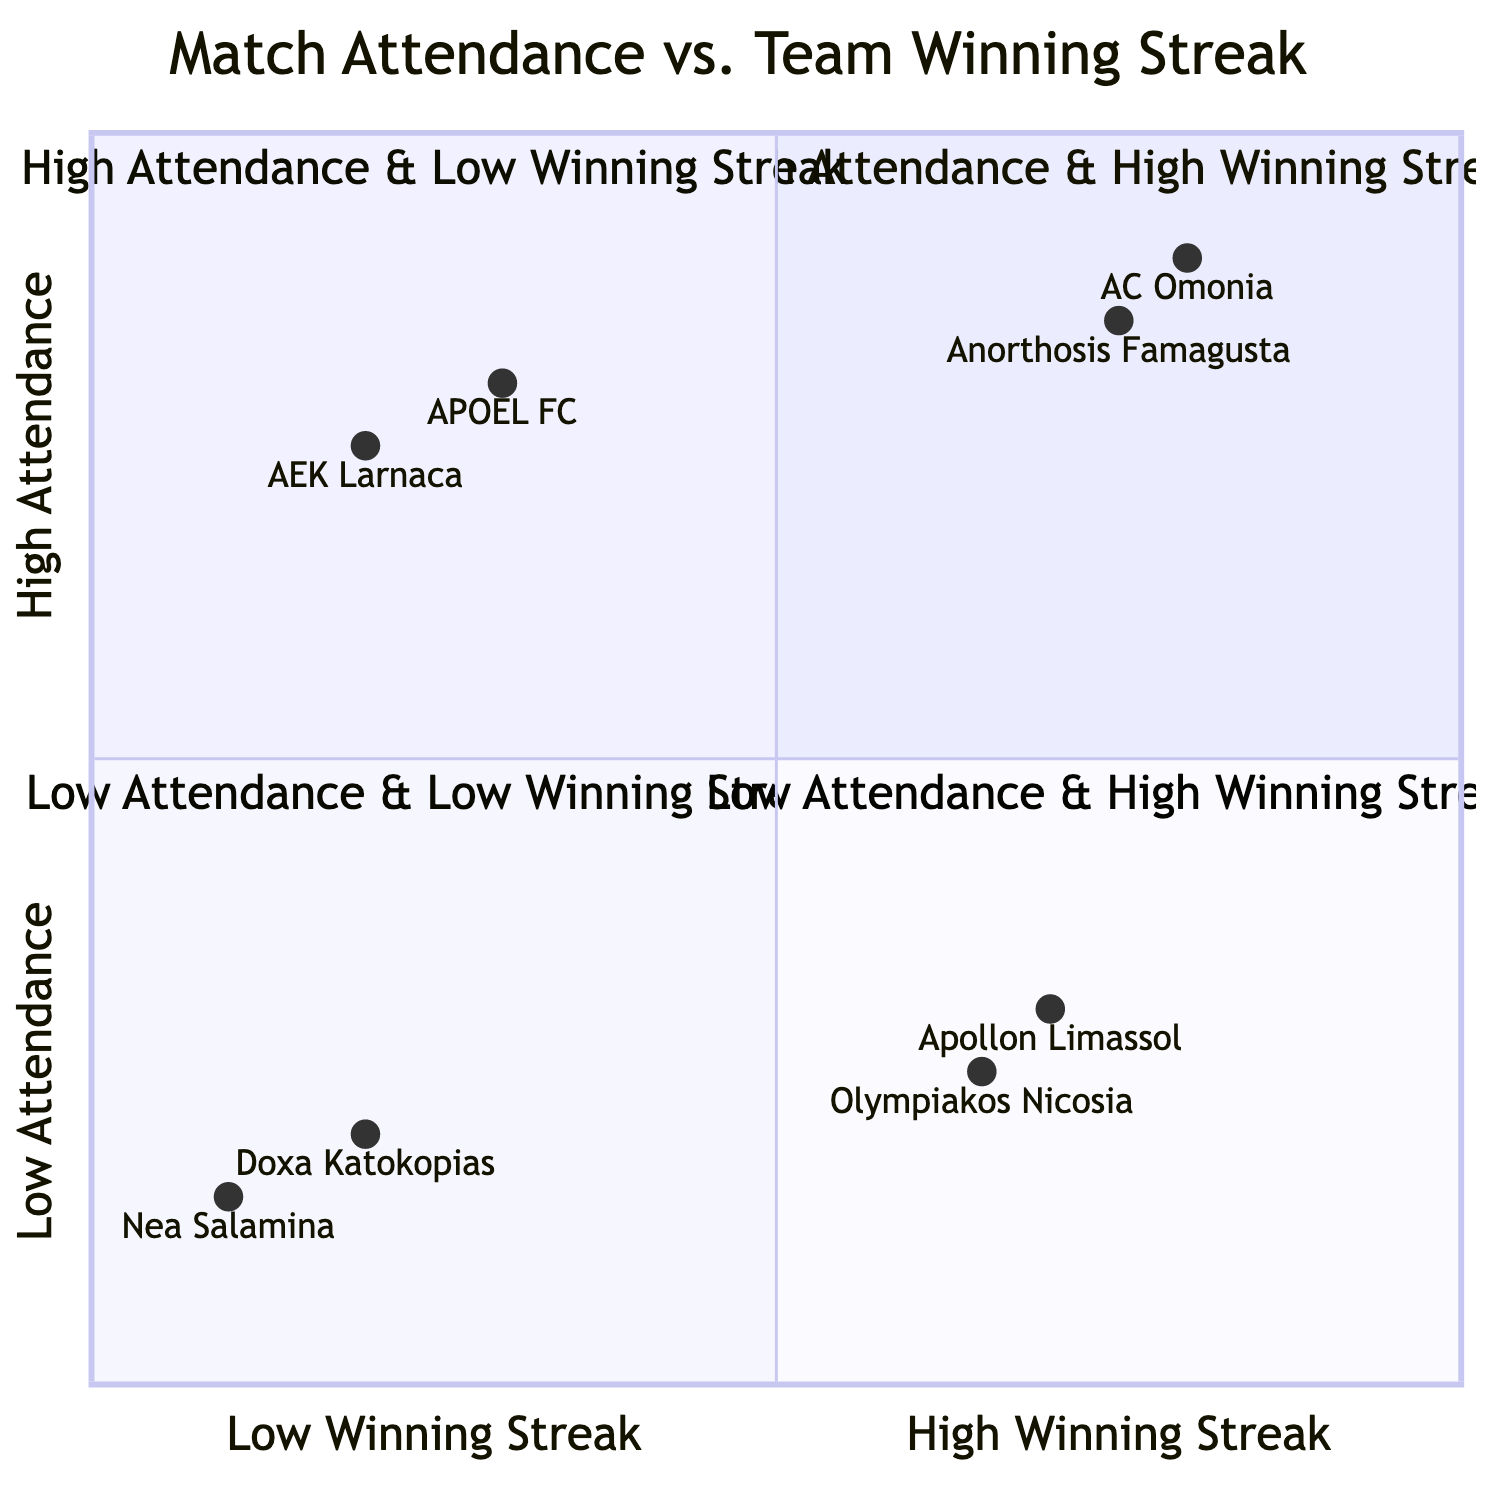What teams are in the High Attendance & High Winning Streak quadrant? In the diagram's High Attendance & High Winning Streak quadrant, the teams listed are AC Omonia and Anorthosis Famagusta.
Answer: AC Omonia, Anorthosis Famagusta How many teams are experiencing Low Attendance & Low Winning Streak? In the Low Attendance & Low Winning Streak quadrant, there are two teams mentioned: Doxa Katokopias and Nea Salamina.
Answer: 2 Which team has High Attendance & Low Winning Streak? The diagram shows that APOEL FC and AEK Larnaca fall in the High Attendance & Low Winning Streak quadrant.
Answer: APOEL FC, AEK Larnaca What is the attendance level of AC Omonia? AC Omonia's position in the diagram indicates a high attendance level, specifically noted as 0.9 on the vertical axis.
Answer: 0.9 Which quadrant has the team with the lowest match attendance? Doxa Katokopias and Nea Salamina are positioned in the Low Attendance & Low Winning Streak quadrant, which denotes the lowest attendance levels.
Answer: Low Attendance & Low Winning Streak What can be inferred about teams in the Low Attendance & High Winning Streak quadrant? The teams Apollon Limassol and Olympiakos Nicosia show high winning streaks but have relatively low attendance numbers, indicating an inconsistency between winning and fan engagement.
Answer: High winning streaks, low attendance Which teams have a higher winning streak, Apollon Limassol or AEK Larnaca? Apollon Limassol is in the Low Attendance & High Winning Streak quadrant with a winning streak level at 0.3, while AEK Larnaca is in the High Attendance & Low Winning Streak quadrant with a lower winning streak level of 0.2.
Answer: Apollon Limassol What characteristic differentiates the High Attendance & Low Winning Streak quadrant from the Low Attendance & High Winning Streak quadrant? The High Attendance & Low Winning Streak quadrant (APOEL FC, AEK Larnaca) features teams that attract fans but do not perform well in matches, while the Low Attendance & High Winning Streak quadrant (Apollon Limassol, Olympiakos Nicosia) showcases teams winning games despite low attendance.
Answer: Attendance vs. performance differentiation 